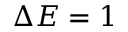<formula> <loc_0><loc_0><loc_500><loc_500>\Delta E = 1</formula> 